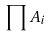<formula> <loc_0><loc_0><loc_500><loc_500>\prod A _ { i }</formula> 